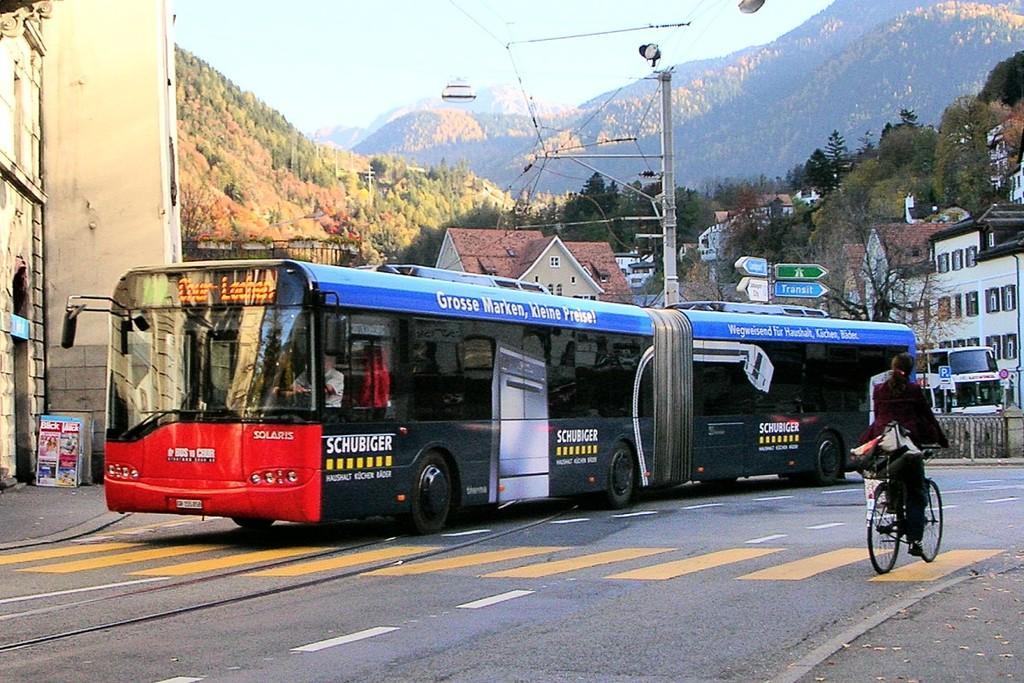Can you describe this image briefly? In this picture we can see a bus traveling on the road, on the right side we can see a person riding bicycle, in the background there are some buildings, we can see a pole here, there are some boards and trees here, we can see the sky at the top of the picture. 